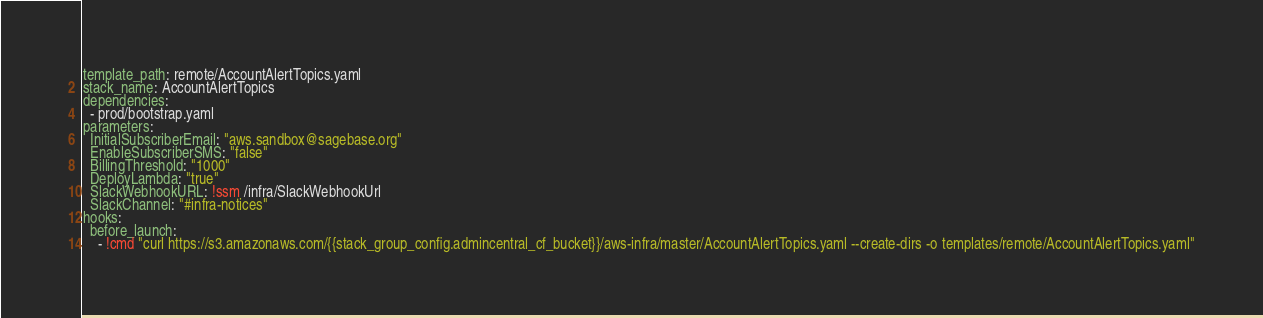<code> <loc_0><loc_0><loc_500><loc_500><_YAML_>template_path: remote/AccountAlertTopics.yaml
stack_name: AccountAlertTopics
dependencies:
  - prod/bootstrap.yaml
parameters:
  InitialSubscriberEmail: "aws.sandbox@sagebase.org"
  EnableSubscriberSMS: "false"
  BillingThreshold: "1000"
  DeployLambda: "true"
  SlackWebhookURL: !ssm /infra/SlackWebhookUrl
  SlackChannel: "#infra-notices"
hooks:
  before_launch:
    - !cmd "curl https://s3.amazonaws.com/{{stack_group_config.admincentral_cf_bucket}}/aws-infra/master/AccountAlertTopics.yaml --create-dirs -o templates/remote/AccountAlertTopics.yaml"
</code> 